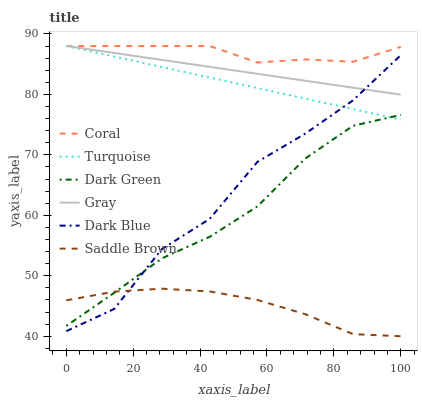Does Saddle Brown have the minimum area under the curve?
Answer yes or no. Yes. Does Coral have the maximum area under the curve?
Answer yes or no. Yes. Does Turquoise have the minimum area under the curve?
Answer yes or no. No. Does Turquoise have the maximum area under the curve?
Answer yes or no. No. Is Turquoise the smoothest?
Answer yes or no. Yes. Is Dark Blue the roughest?
Answer yes or no. Yes. Is Coral the smoothest?
Answer yes or no. No. Is Coral the roughest?
Answer yes or no. No. Does Turquoise have the lowest value?
Answer yes or no. No. Does Coral have the highest value?
Answer yes or no. Yes. Does Dark Blue have the highest value?
Answer yes or no. No. Is Saddle Brown less than Turquoise?
Answer yes or no. Yes. Is Gray greater than Dark Green?
Answer yes or no. Yes. Does Dark Blue intersect Gray?
Answer yes or no. Yes. Is Dark Blue less than Gray?
Answer yes or no. No. Is Dark Blue greater than Gray?
Answer yes or no. No. Does Saddle Brown intersect Turquoise?
Answer yes or no. No. 